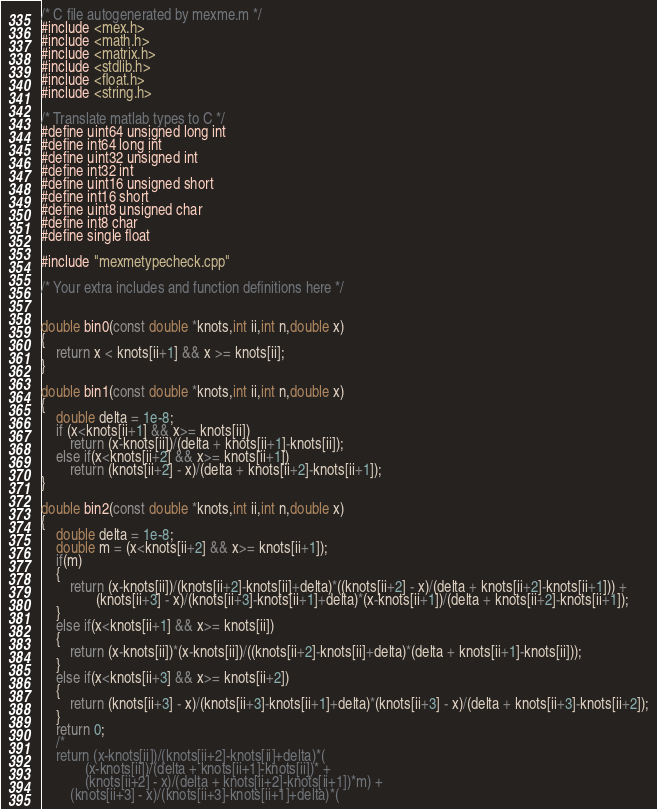<code> <loc_0><loc_0><loc_500><loc_500><_C++_>/* C file autogenerated by mexme.m */
#include <mex.h>
#include <math.h>
#include <matrix.h>
#include <stdlib.h>
#include <float.h>
#include <string.h>

/* Translate matlab types to C */
#define uint64 unsigned long int
#define int64 long int
#define uint32 unsigned int
#define int32 int
#define uint16 unsigned short
#define int16 short
#define uint8 unsigned char
#define int8 char
#define single float

#include "mexmetypecheck.cpp"

/* Your extra includes and function definitions here */


double bin0(const double *knots,int ii,int n,double x)
{
    return x < knots[ii+1] && x >= knots[ii];
}

double bin1(const double *knots,int ii,int n,double x)
{
    double delta = 1e-8;
    if (x<knots[ii+1] && x>= knots[ii])
        return (x-knots[ii])/(delta + knots[ii+1]-knots[ii]);
    else if(x<knots[ii+2] && x>= knots[ii+1])
        return (knots[ii+2] - x)/(delta + knots[ii+2]-knots[ii+1]);
}

double bin2(const double *knots,int ii,int n,double x)
{
    double delta = 1e-8;
    double m = (x<knots[ii+2] && x>= knots[ii+1]);
    if(m)
    {
        return (x-knots[ii])/(knots[ii+2]-knots[ii]+delta)*((knots[ii+2] - x)/(delta + knots[ii+2]-knots[ii+1])) + 
               (knots[ii+3] - x)/(knots[ii+3]-knots[ii+1]+delta)*(x-knots[ii+1])/(delta + knots[ii+2]-knots[ii+1]);
    }
    else if(x<knots[ii+1] && x>= knots[ii])
    {
        return (x-knots[ii])*(x-knots[ii])/((knots[ii+2]-knots[ii]+delta)*(delta + knots[ii+1]-knots[ii]));
    }
    else if(x<knots[ii+3] && x>= knots[ii+2])
    {
        return (knots[ii+3] - x)/(knots[ii+3]-knots[ii+1]+delta)*(knots[ii+3] - x)/(delta + knots[ii+3]-knots[ii+2]);
    }
    return 0;
    /*
    return (x-knots[ii])/(knots[ii+2]-knots[ii]+delta)*(  
            (x-knots[ii])/(delta + knots[ii+1]-knots[ii])* + 
            (knots[ii+2] - x)/(delta + knots[ii+2]-knots[ii+1])*m) + 
        (knots[ii+3] - x)/(knots[ii+3]-knots[ii+1]+delta)*(</code> 